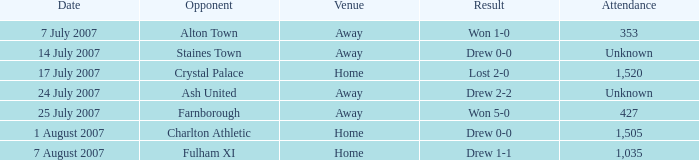Tell me the date with result of won 1-0 7 July 2007. 